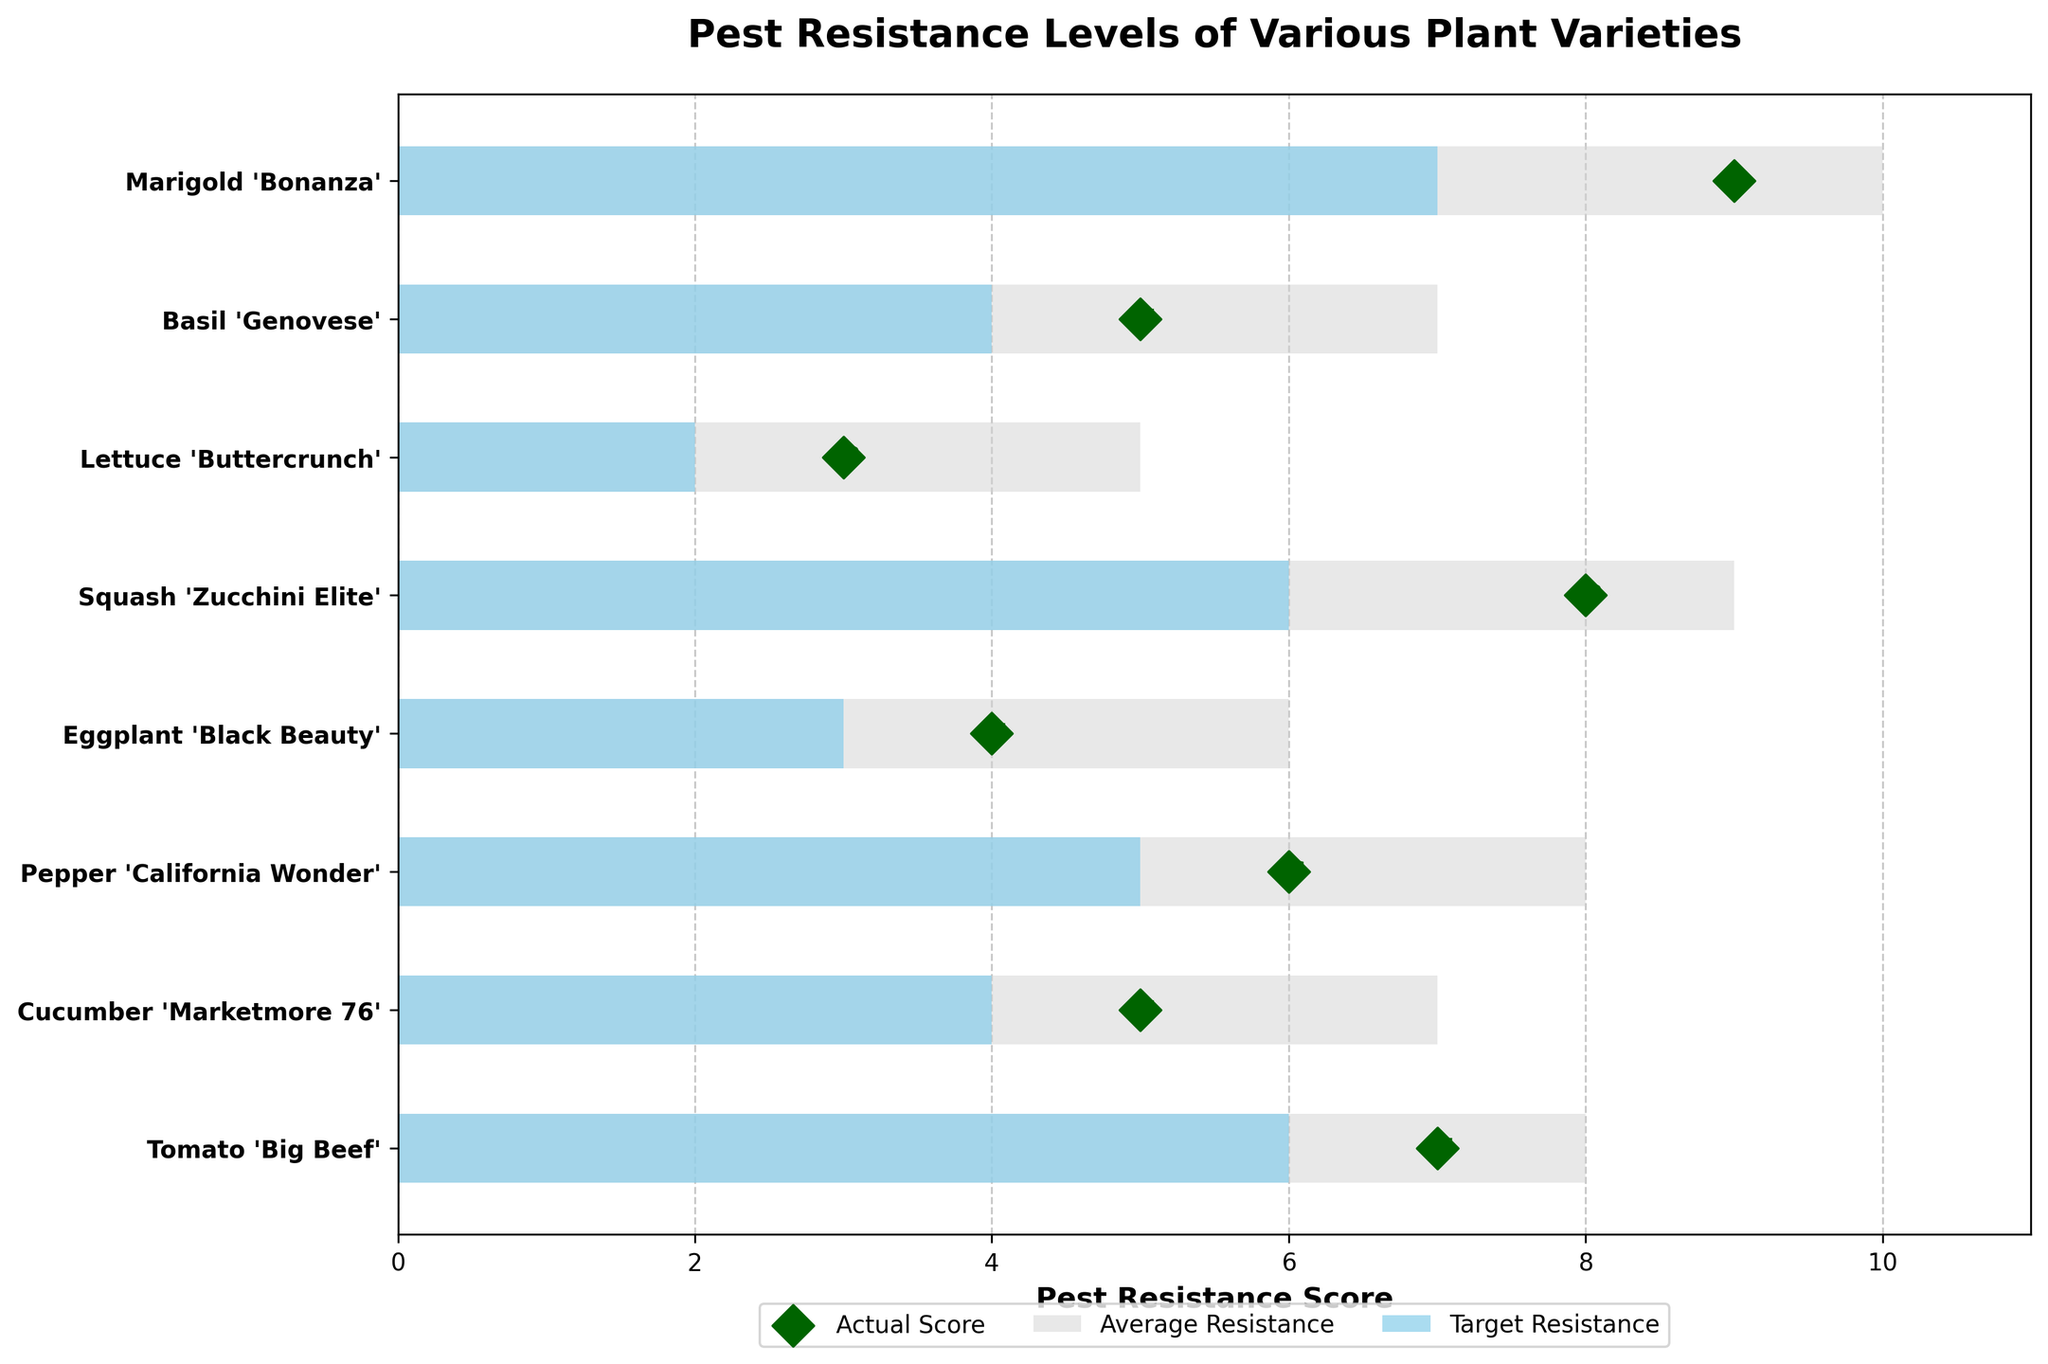What is the title of the figure? The title of the figure is located at the top and is meant to describe the subject of the plot. The title here is "Pest Resistance Levels of Various Plant Varieties".
Answer: Pest Resistance Levels of Various Plant Varieties How many plant varieties are depicted in the chart? To determine the number of plant varieties, count the labels on the y-axis. The y-axis lists 8 plant varieties.
Answer: 8 Which plant variety has the highest pest resistance score? Look for the largest marker on the scatter plot along the Pest Resistance Score axis. The highest pest resistance score is 9 for Marigold 'Bonanza'.
Answer: Marigold 'Bonanza' What is the average pest resistance score for 'Pepper 'California Wonder''? Identify the 'Pepper 'California Wonder'' on the y-axis and follow it to the corresponding bar denoting the Average Resistance score. The average resistance is 5.
Answer: 5 What is the difference between the pest resistance score and the target resistance for 'Lettuce 'Buttercrunch''? Find 'Lettuce 'Buttercrunch'' on the y-axis, identify its pest resistance score (3), and its target resistance (5). Subtract the pest resistance score from the target: 5 - 3 = 2.
Answer: 2 Which plant variety is closest to meeting its target resistance? Compare each plant variety's pest resistance score with its target resistance score visually. 'Squash 'Zucchini Elite'' has a pest resistance score of 8, and its target resistance is 9, making it the closest with a difference of 1.
Answer: Squash 'Zucchini Elite' Which plant variety shows the greatest deficit in pest resistance relative to its target? Check for the largest negative difference between pest resistance score and target resistance. 'Lettuce 'Buttercrunch'' shows the greatest deficit: 5 (target) - 3 (actual) = 2.
Answer: Lettuce 'Buttercrunch' What color represents the average resistance in the plot, and how do you know? The average resistance is represented by the color shown in the larger background bar (middle one) in each set: sky blue. The legend also indicates this.
Answer: Sky blue How much higher is the target resistance compared to the average resistance for 'Cucumber 'Marketmore 76''? Locate 'Cucumber 'Marketmore 76'' on the y-axis, the target resistance is 7, and the average resistance is 4. The difference is 7 - 4 = 3.
Answer: 3 Which plant varieties have an actual pest resistance score higher than their average resistance? Identify plant varieties where the scatter plot marker is to the right of the average resistance bar: 'Tomato 'Big Beef'', 'Pepper 'California Wonder'', 'Squash 'Zucchini Elite'', 'Marigold 'Bonanza''.
Answer: Tomato 'Big Beef', Pepper 'California Wonder', Squash 'Zucchini Elite', Marigold 'Bonanza' 